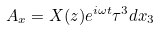Convert formula to latex. <formula><loc_0><loc_0><loc_500><loc_500>A _ { x } = X ( z ) e ^ { i \omega t } \tau ^ { 3 } d x _ { 3 }</formula> 